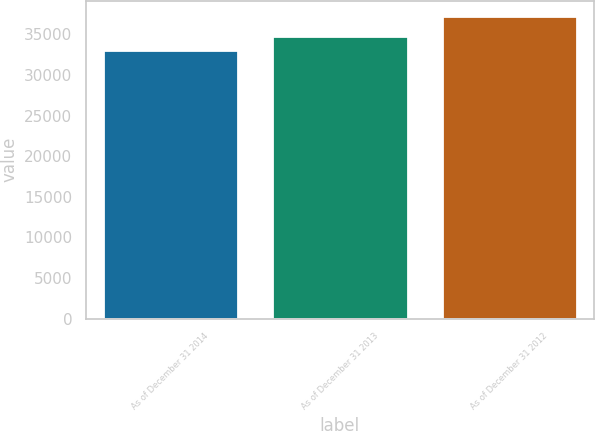Convert chart. <chart><loc_0><loc_0><loc_500><loc_500><bar_chart><fcel>As of December 31 2014<fcel>As of December 31 2013<fcel>As of December 31 2012<nl><fcel>33075<fcel>34784<fcel>37306<nl></chart> 